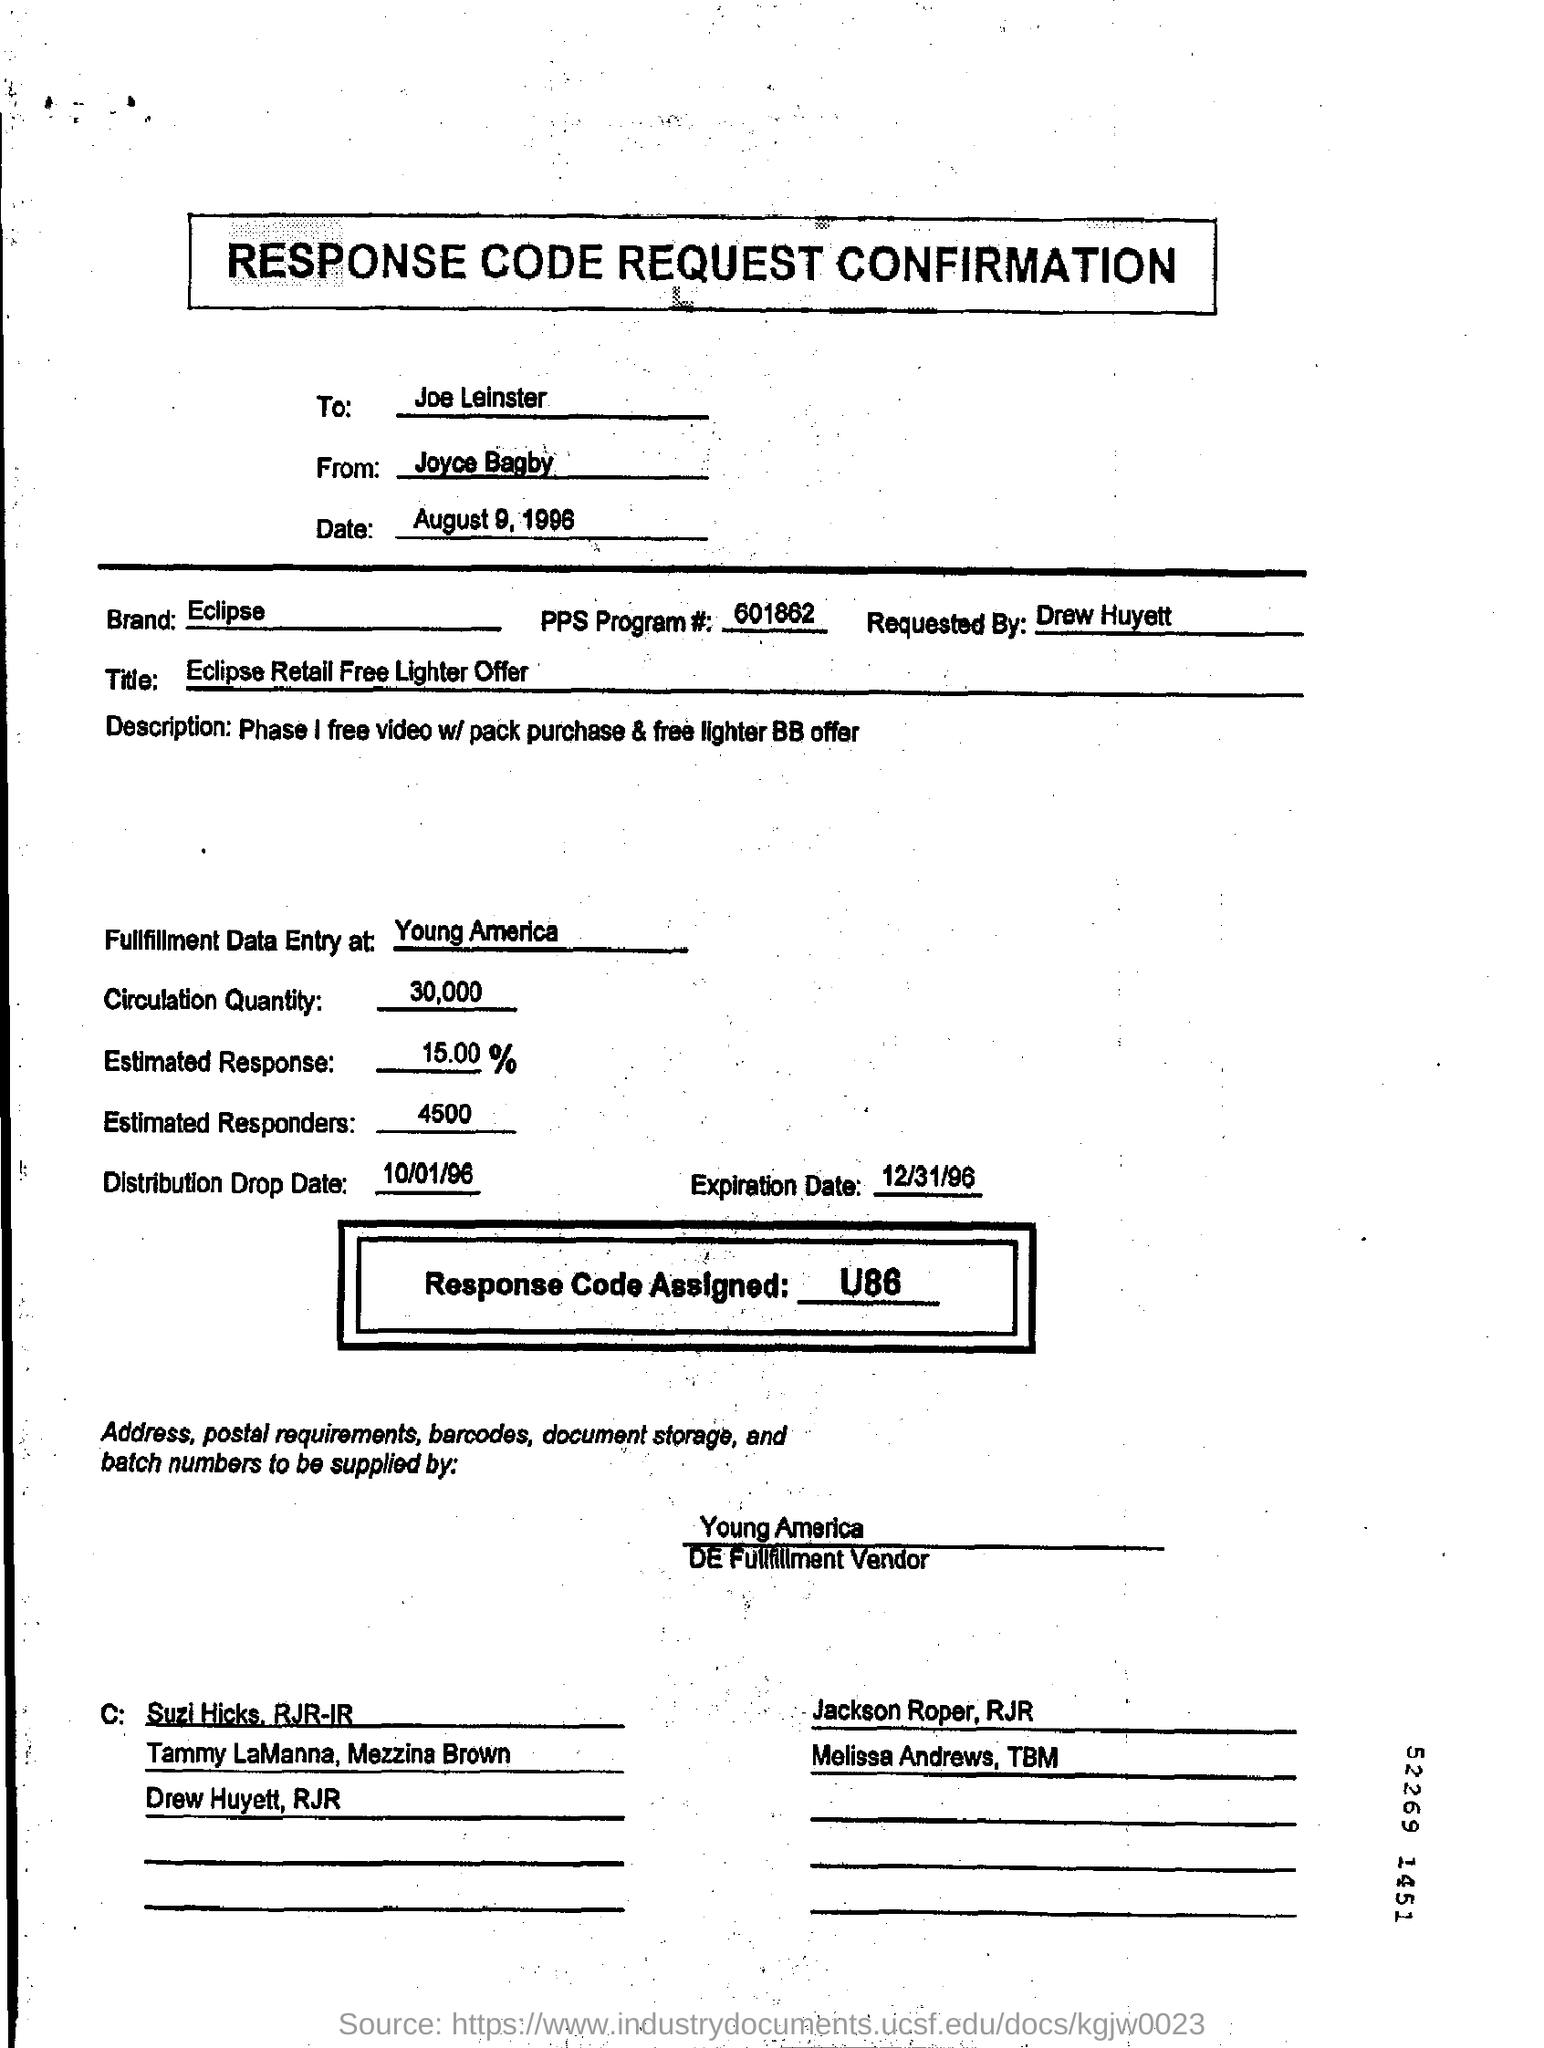Mention a couple of crucial points in this snapshot. The location of the fulfillment data entry for Young America is? The circulation quantity is 30,000. It has been requested by Drew Huyett. The date is August 9, 1996. The assigned response code is U86... 